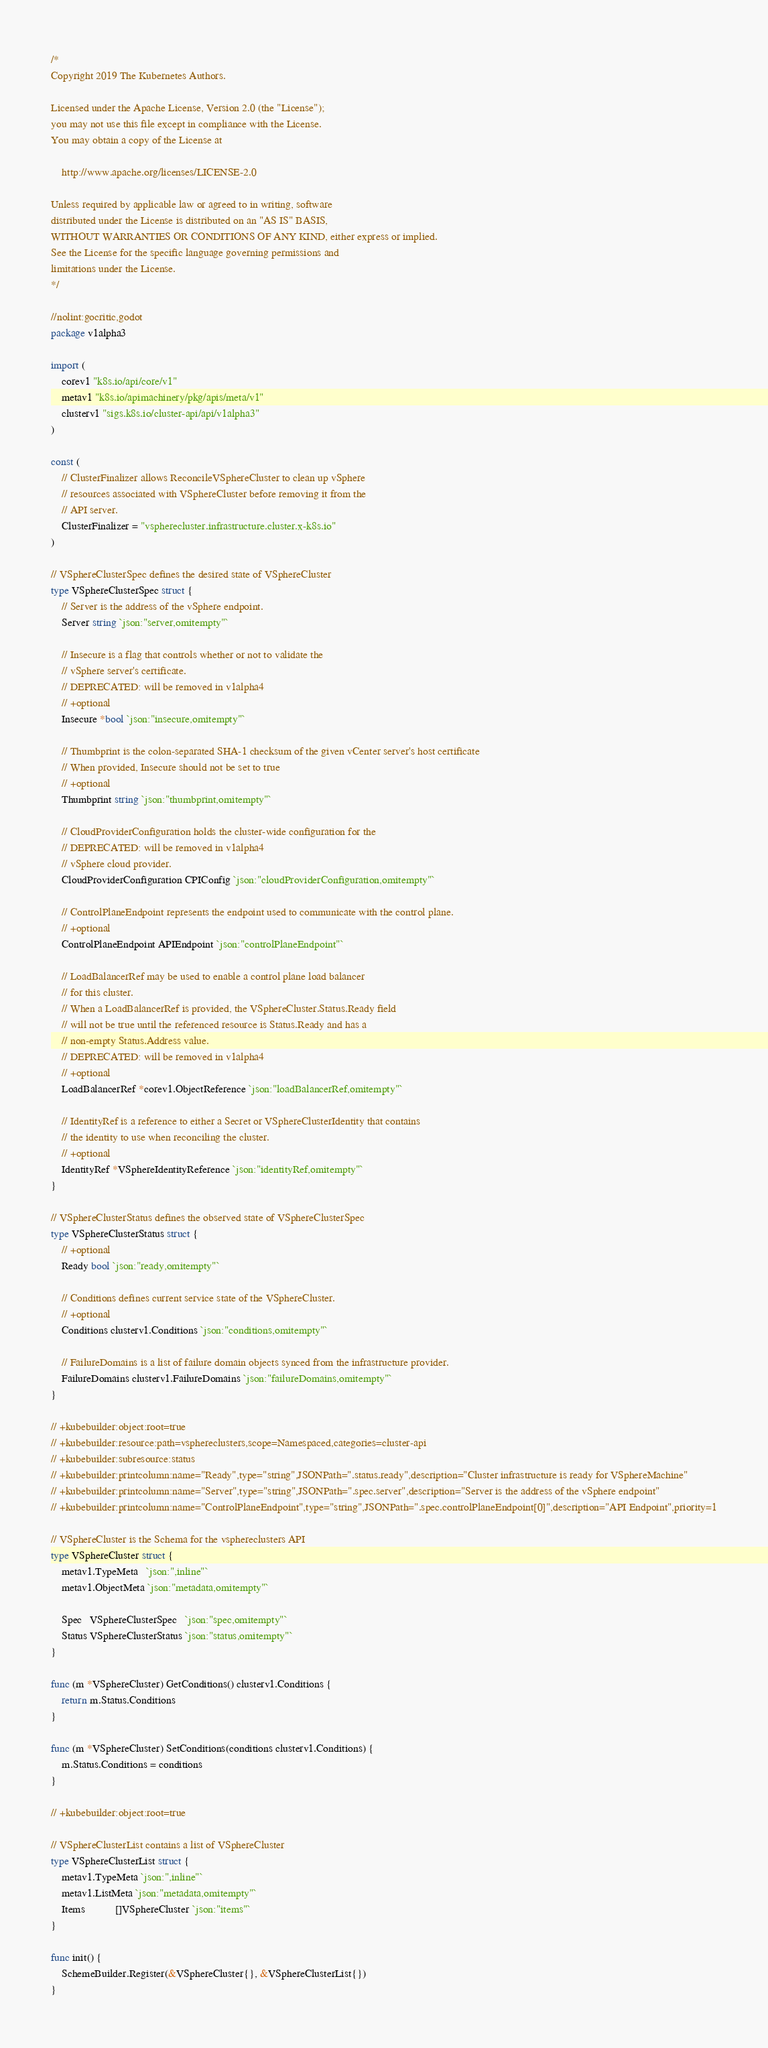Convert code to text. <code><loc_0><loc_0><loc_500><loc_500><_Go_>/*
Copyright 2019 The Kubernetes Authors.

Licensed under the Apache License, Version 2.0 (the "License");
you may not use this file except in compliance with the License.
You may obtain a copy of the License at

    http://www.apache.org/licenses/LICENSE-2.0

Unless required by applicable law or agreed to in writing, software
distributed under the License is distributed on an "AS IS" BASIS,
WITHOUT WARRANTIES OR CONDITIONS OF ANY KIND, either express or implied.
See the License for the specific language governing permissions and
limitations under the License.
*/

//nolint:gocritic,godot
package v1alpha3

import (
	corev1 "k8s.io/api/core/v1"
	metav1 "k8s.io/apimachinery/pkg/apis/meta/v1"
	clusterv1 "sigs.k8s.io/cluster-api/api/v1alpha3"
)

const (
	// ClusterFinalizer allows ReconcileVSphereCluster to clean up vSphere
	// resources associated with VSphereCluster before removing it from the
	// API server.
	ClusterFinalizer = "vspherecluster.infrastructure.cluster.x-k8s.io"
)

// VSphereClusterSpec defines the desired state of VSphereCluster
type VSphereClusterSpec struct {
	// Server is the address of the vSphere endpoint.
	Server string `json:"server,omitempty"`

	// Insecure is a flag that controls whether or not to validate the
	// vSphere server's certificate.
	// DEPRECATED: will be removed in v1alpha4
	// +optional
	Insecure *bool `json:"insecure,omitempty"`

	// Thumbprint is the colon-separated SHA-1 checksum of the given vCenter server's host certificate
	// When provided, Insecure should not be set to true
	// +optional
	Thumbprint string `json:"thumbprint,omitempty"`

	// CloudProviderConfiguration holds the cluster-wide configuration for the
	// DEPRECATED: will be removed in v1alpha4
	// vSphere cloud provider.
	CloudProviderConfiguration CPIConfig `json:"cloudProviderConfiguration,omitempty"`

	// ControlPlaneEndpoint represents the endpoint used to communicate with the control plane.
	// +optional
	ControlPlaneEndpoint APIEndpoint `json:"controlPlaneEndpoint"`

	// LoadBalancerRef may be used to enable a control plane load balancer
	// for this cluster.
	// When a LoadBalancerRef is provided, the VSphereCluster.Status.Ready field
	// will not be true until the referenced resource is Status.Ready and has a
	// non-empty Status.Address value.
	// DEPRECATED: will be removed in v1alpha4
	// +optional
	LoadBalancerRef *corev1.ObjectReference `json:"loadBalancerRef,omitempty"`

	// IdentityRef is a reference to either a Secret or VSphereClusterIdentity that contains
	// the identity to use when reconciling the cluster.
	// +optional
	IdentityRef *VSphereIdentityReference `json:"identityRef,omitempty"`
}

// VSphereClusterStatus defines the observed state of VSphereClusterSpec
type VSphereClusterStatus struct {
	// +optional
	Ready bool `json:"ready,omitempty"`

	// Conditions defines current service state of the VSphereCluster.
	// +optional
	Conditions clusterv1.Conditions `json:"conditions,omitempty"`

	// FailureDomains is a list of failure domain objects synced from the infrastructure provider.
	FailureDomains clusterv1.FailureDomains `json:"failureDomains,omitempty"`
}

// +kubebuilder:object:root=true
// +kubebuilder:resource:path=vsphereclusters,scope=Namespaced,categories=cluster-api
// +kubebuilder:subresource:status
// +kubebuilder:printcolumn:name="Ready",type="string",JSONPath=".status.ready",description="Cluster infrastructure is ready for VSphereMachine"
// +kubebuilder:printcolumn:name="Server",type="string",JSONPath=".spec.server",description="Server is the address of the vSphere endpoint"
// +kubebuilder:printcolumn:name="ControlPlaneEndpoint",type="string",JSONPath=".spec.controlPlaneEndpoint[0]",description="API Endpoint",priority=1

// VSphereCluster is the Schema for the vsphereclusters API
type VSphereCluster struct {
	metav1.TypeMeta   `json:",inline"`
	metav1.ObjectMeta `json:"metadata,omitempty"`

	Spec   VSphereClusterSpec   `json:"spec,omitempty"`
	Status VSphereClusterStatus `json:"status,omitempty"`
}

func (m *VSphereCluster) GetConditions() clusterv1.Conditions {
	return m.Status.Conditions
}

func (m *VSphereCluster) SetConditions(conditions clusterv1.Conditions) {
	m.Status.Conditions = conditions
}

// +kubebuilder:object:root=true

// VSphereClusterList contains a list of VSphereCluster
type VSphereClusterList struct {
	metav1.TypeMeta `json:",inline"`
	metav1.ListMeta `json:"metadata,omitempty"`
	Items           []VSphereCluster `json:"items"`
}

func init() {
	SchemeBuilder.Register(&VSphereCluster{}, &VSphereClusterList{})
}
</code> 